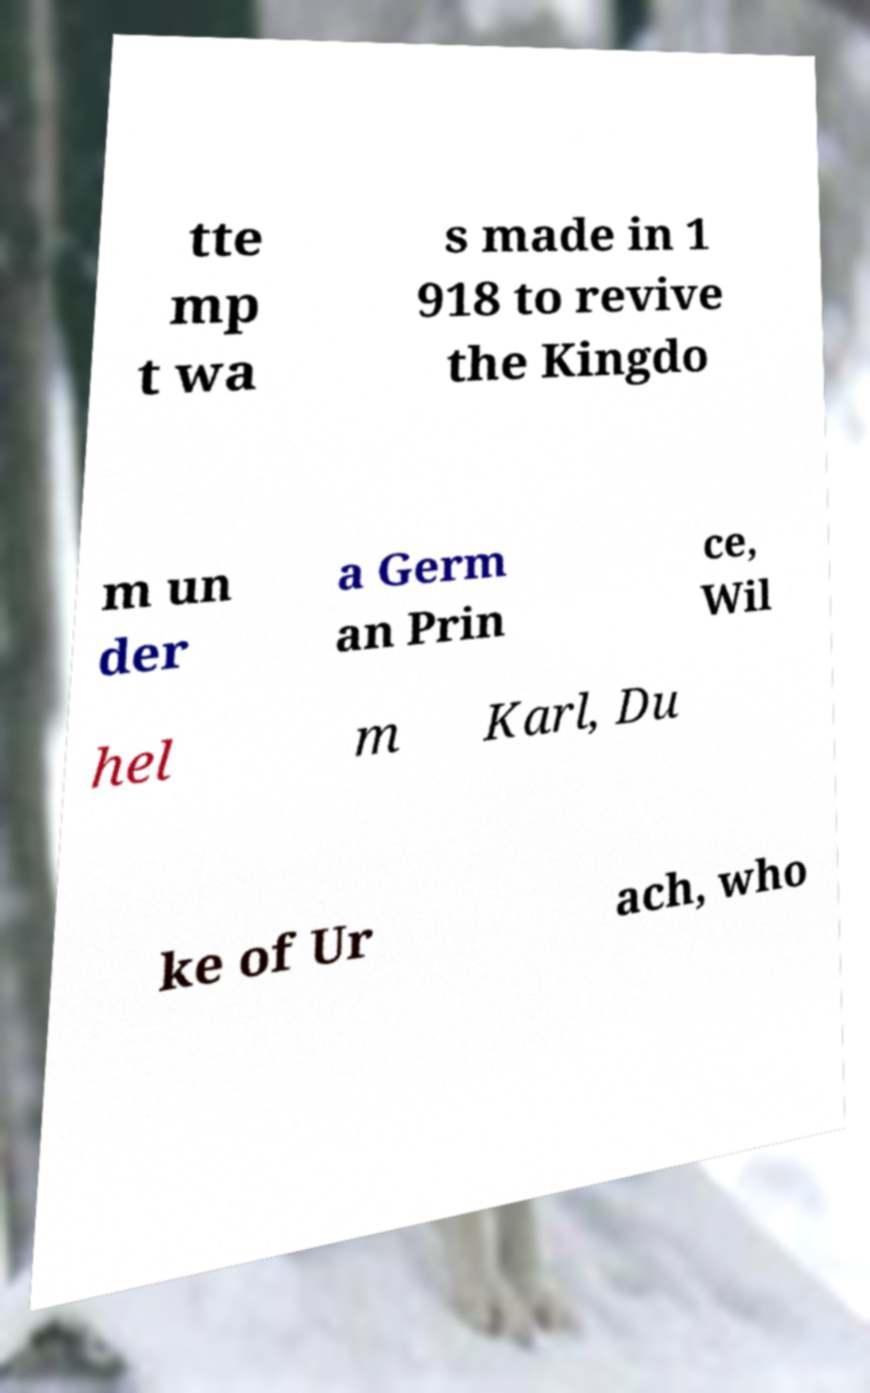I need the written content from this picture converted into text. Can you do that? tte mp t wa s made in 1 918 to revive the Kingdo m un der a Germ an Prin ce, Wil hel m Karl, Du ke of Ur ach, who 